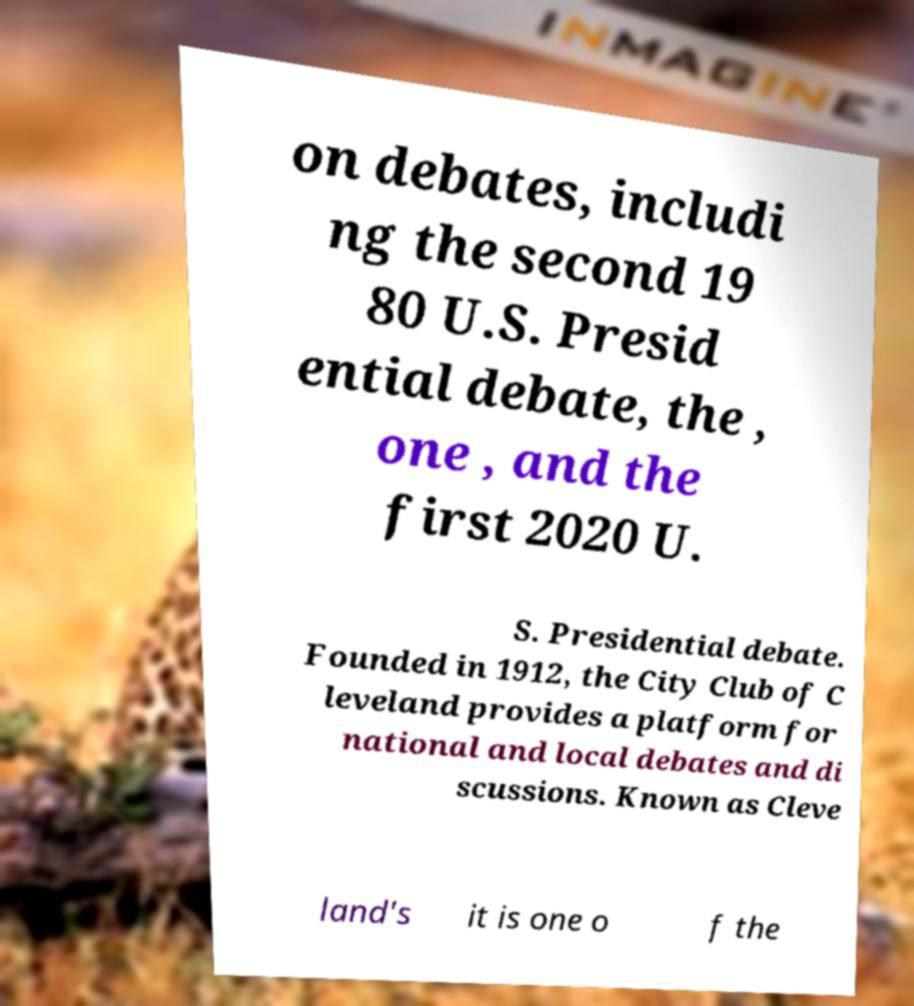For documentation purposes, I need the text within this image transcribed. Could you provide that? on debates, includi ng the second 19 80 U.S. Presid ential debate, the , one , and the first 2020 U. S. Presidential debate. Founded in 1912, the City Club of C leveland provides a platform for national and local debates and di scussions. Known as Cleve land's it is one o f the 